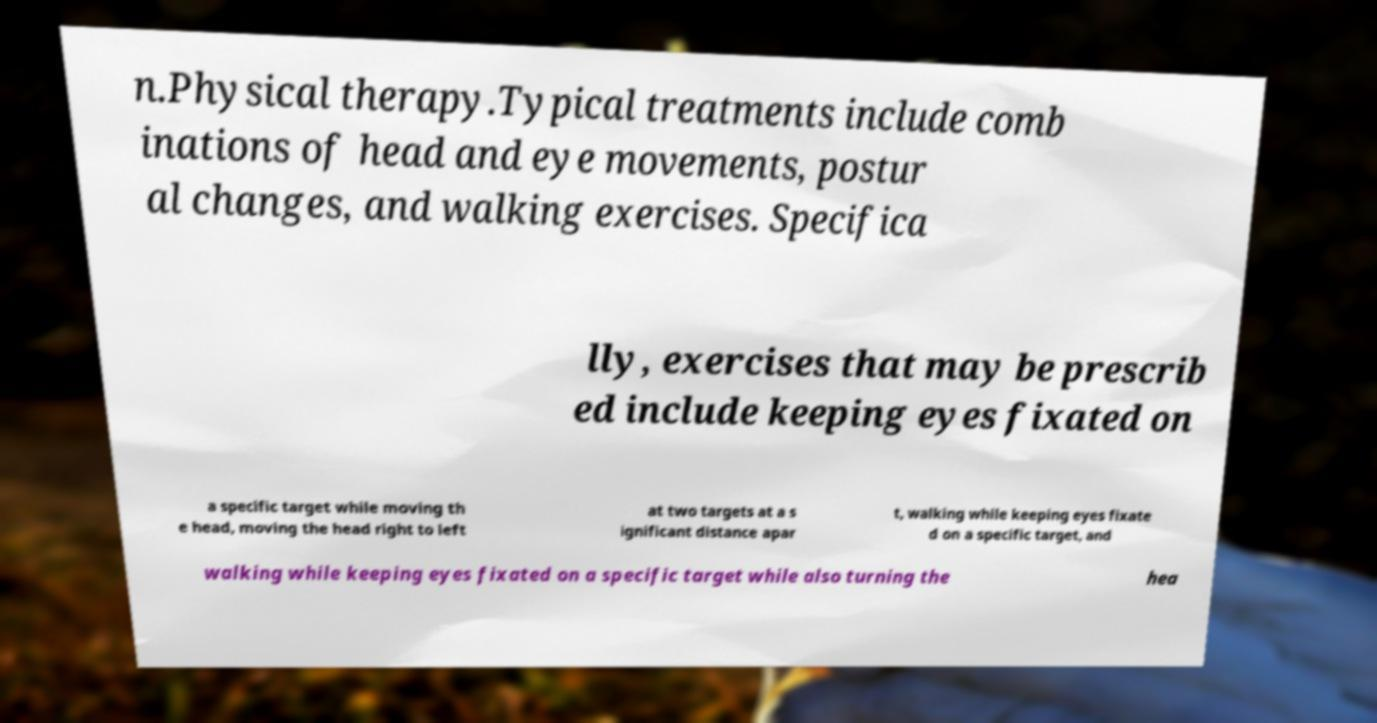There's text embedded in this image that I need extracted. Can you transcribe it verbatim? n.Physical therapy.Typical treatments include comb inations of head and eye movements, postur al changes, and walking exercises. Specifica lly, exercises that may be prescrib ed include keeping eyes fixated on a specific target while moving th e head, moving the head right to left at two targets at a s ignificant distance apar t, walking while keeping eyes fixate d on a specific target, and walking while keeping eyes fixated on a specific target while also turning the hea 